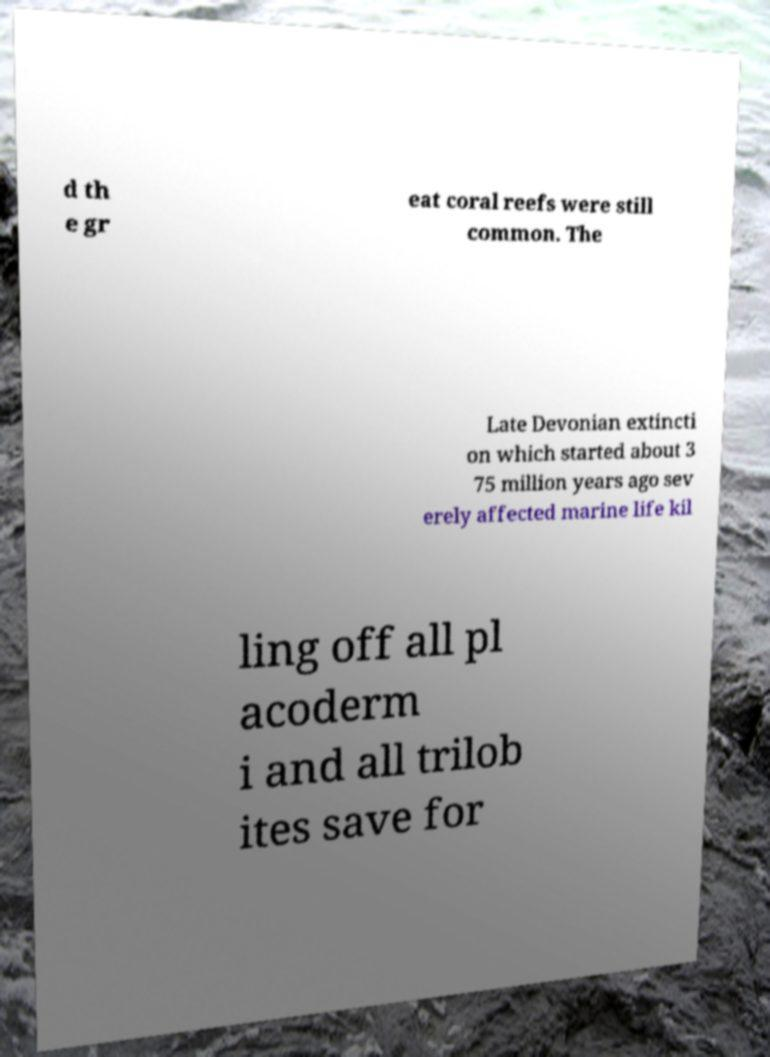Can you accurately transcribe the text from the provided image for me? d th e gr eat coral reefs were still common. The Late Devonian extincti on which started about 3 75 million years ago sev erely affected marine life kil ling off all pl acoderm i and all trilob ites save for 